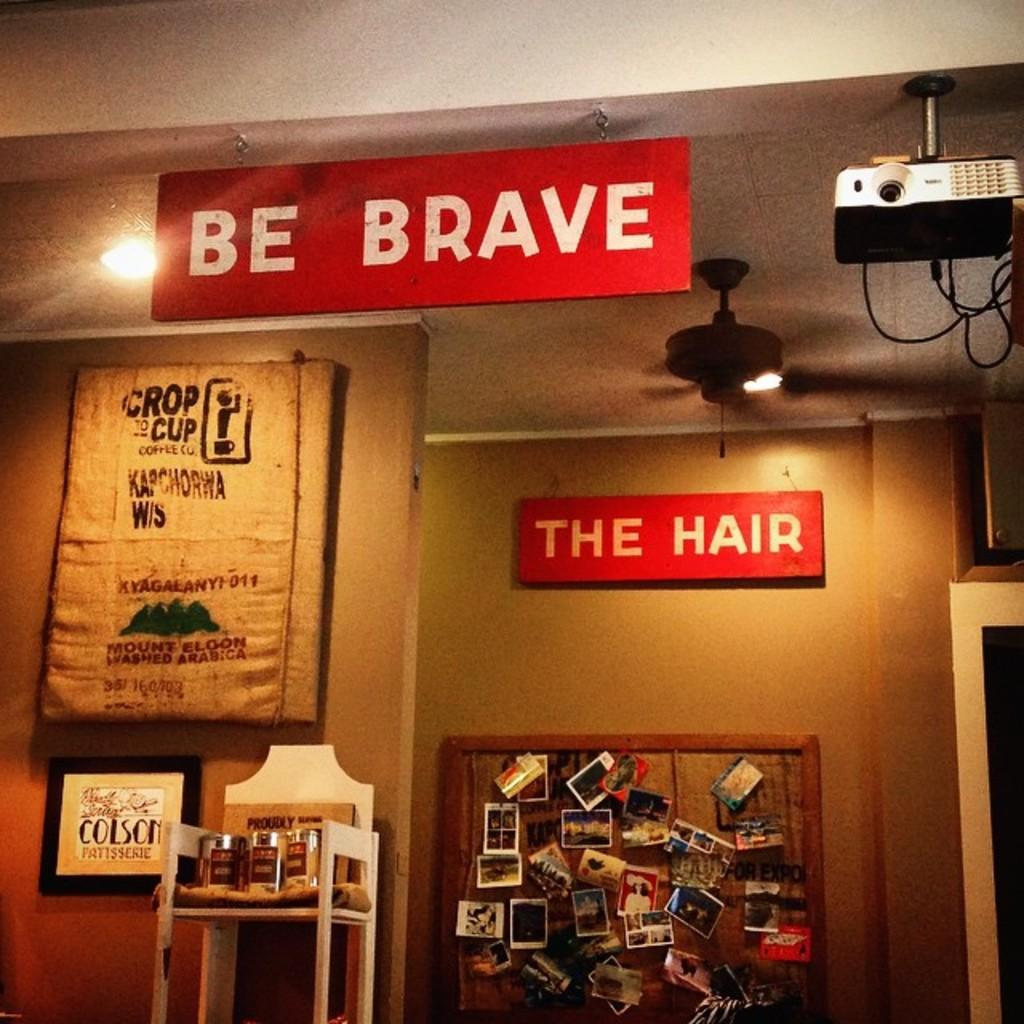<image>
Write a terse but informative summary of the picture. A wall with several picture on it and a sign that says Be Brave. 